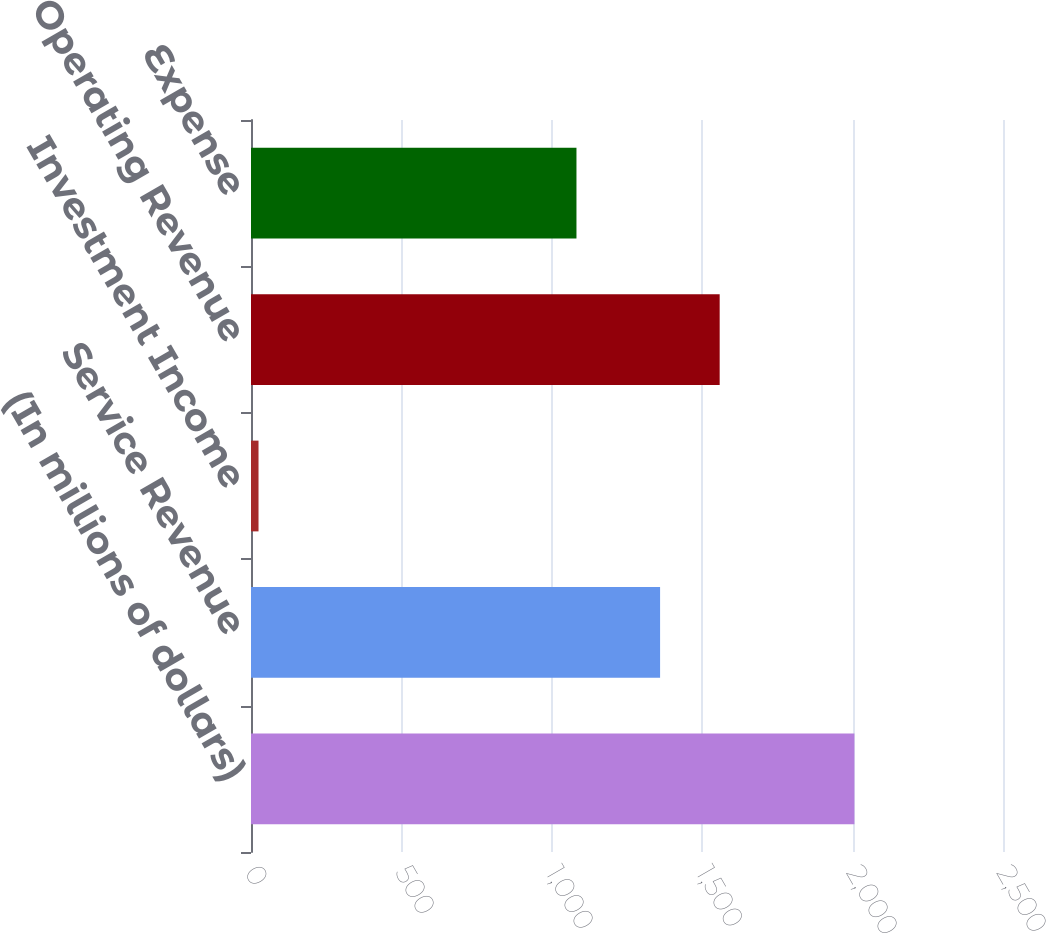<chart> <loc_0><loc_0><loc_500><loc_500><bar_chart><fcel>(In millions of dollars)<fcel>Service Revenue<fcel>Investment Income<fcel>Operating Revenue<fcel>Expense<nl><fcel>2006<fcel>1360<fcel>25<fcel>1558.1<fcel>1082<nl></chart> 